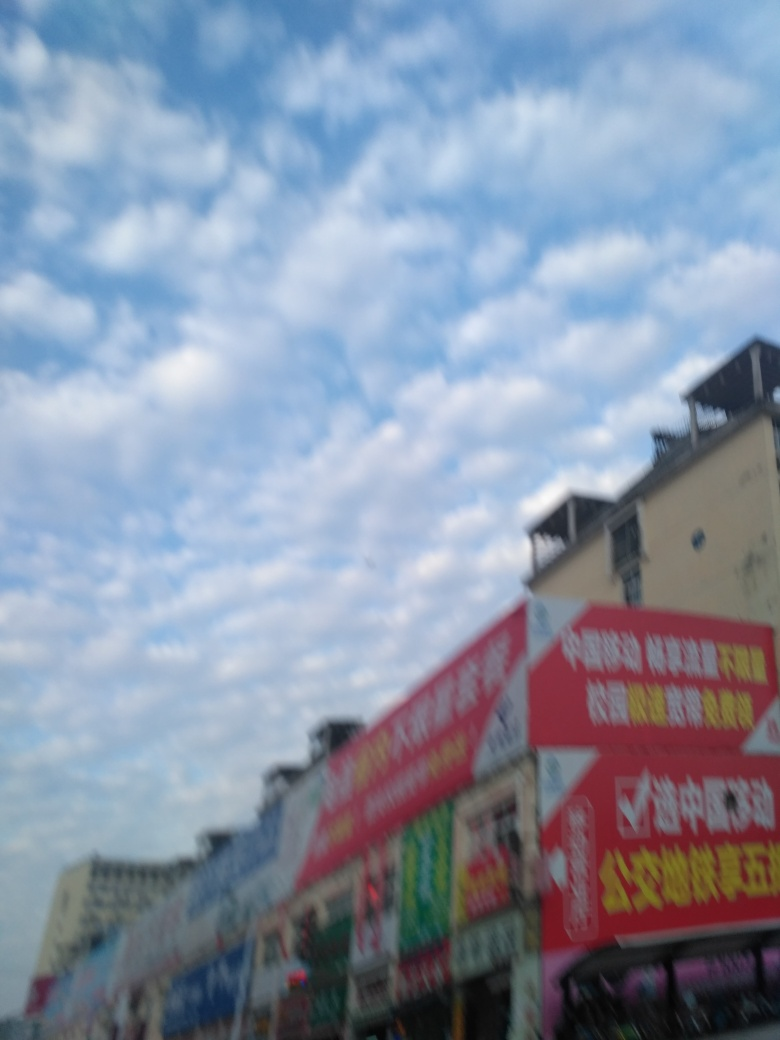Is the main subject of the image a small shop on the roadside? The image appears to show a row of shops along a roadside, but the focus is blurry, making it difficult to determine the size of the shops or to provide specific details about the main subject. 